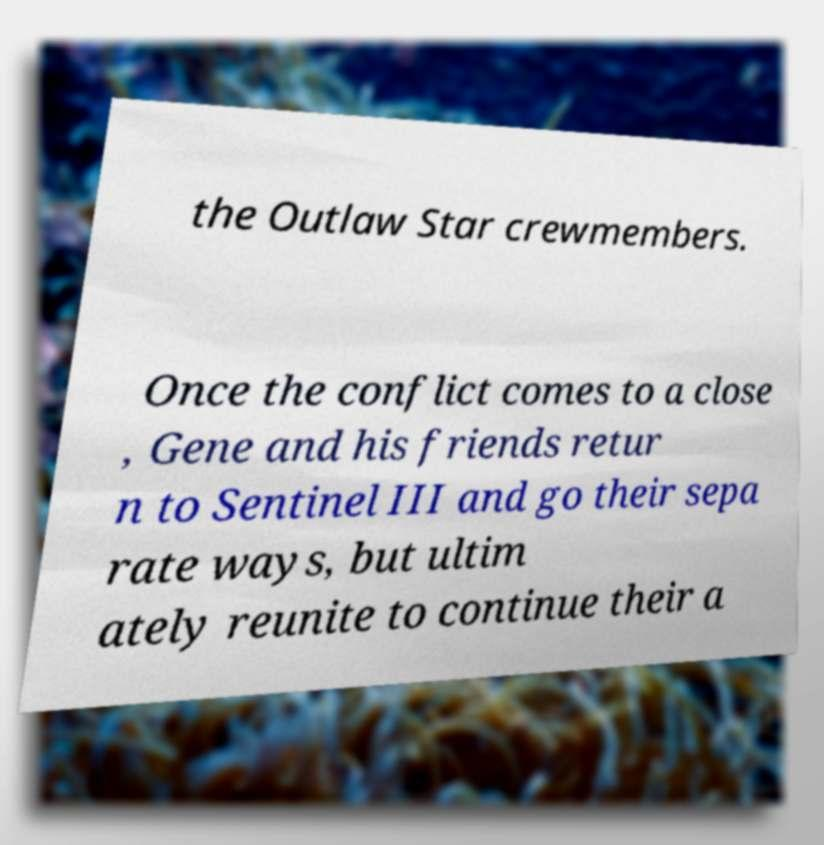Could you assist in decoding the text presented in this image and type it out clearly? the Outlaw Star crewmembers. Once the conflict comes to a close , Gene and his friends retur n to Sentinel III and go their sepa rate ways, but ultim ately reunite to continue their a 